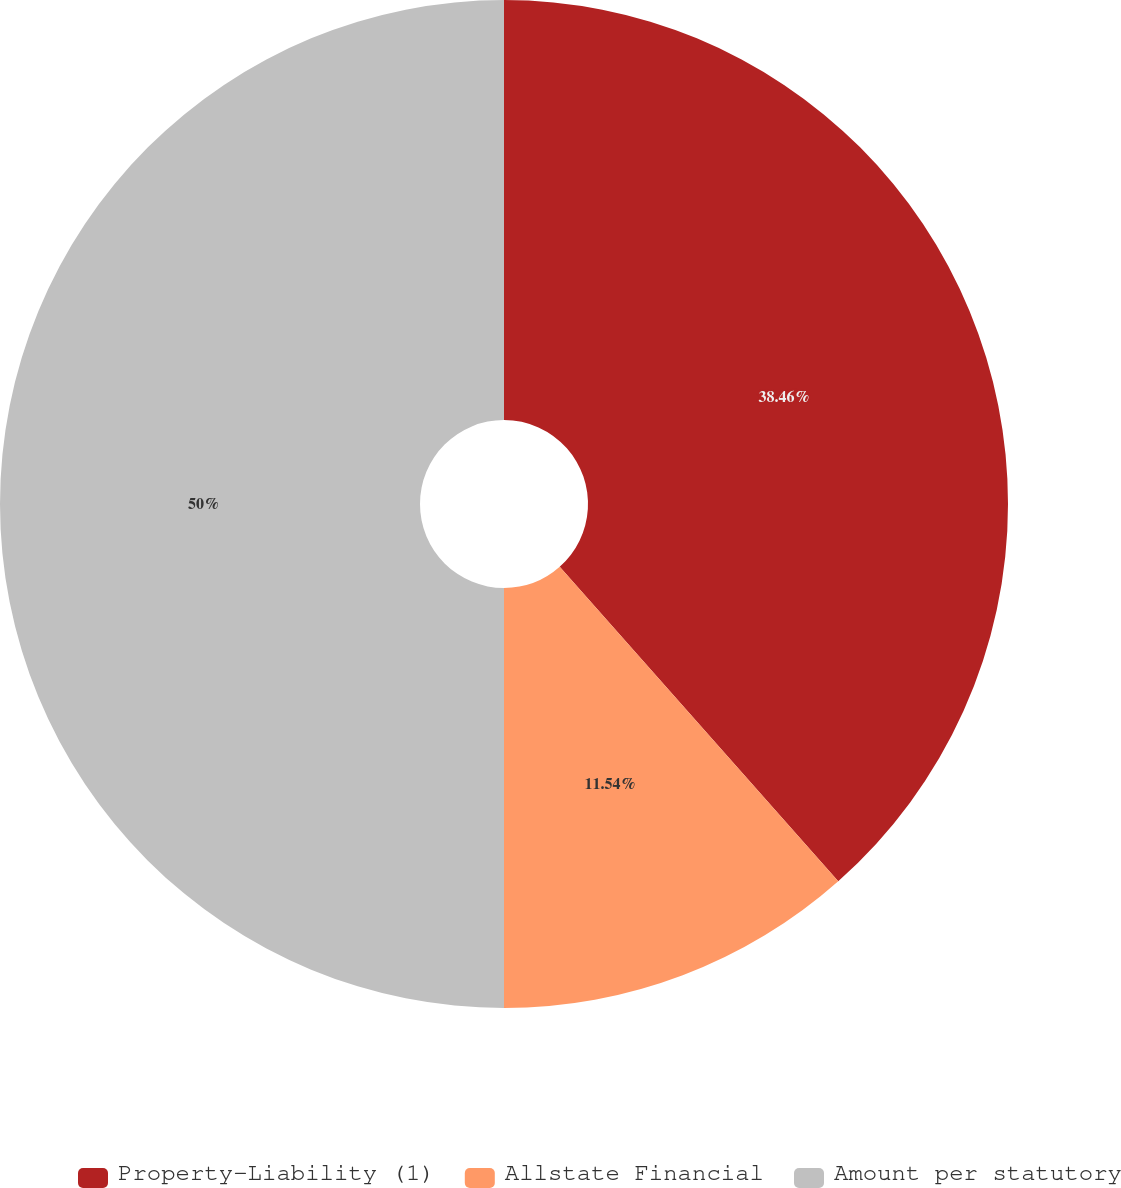<chart> <loc_0><loc_0><loc_500><loc_500><pie_chart><fcel>Property-Liability (1)<fcel>Allstate Financial<fcel>Amount per statutory<nl><fcel>38.46%<fcel>11.54%<fcel>50.0%<nl></chart> 